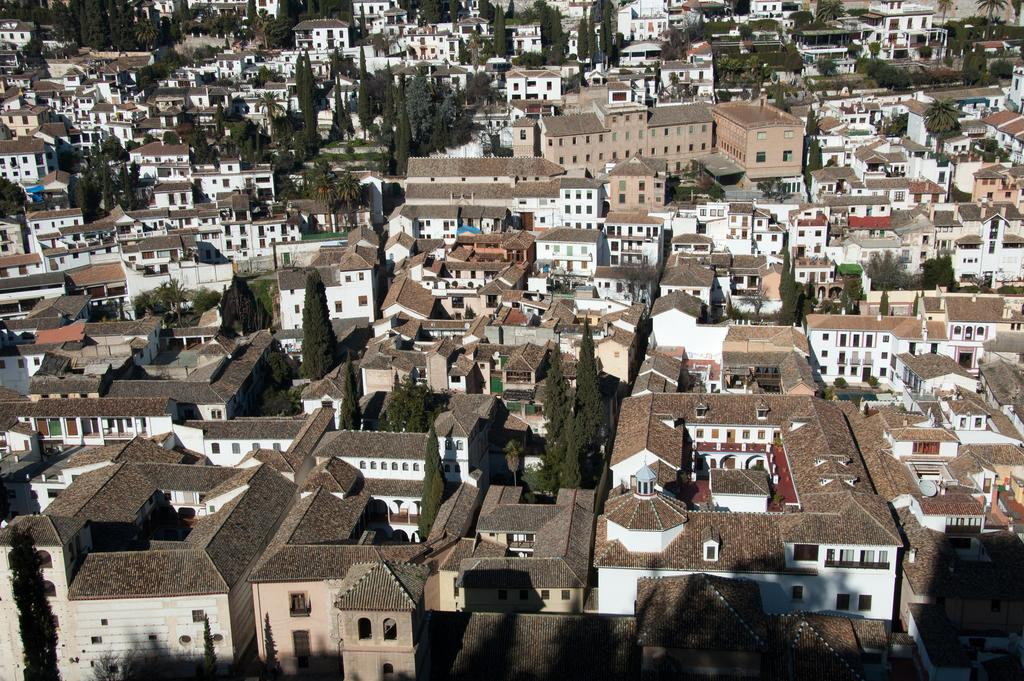What types of structures are visible in the image? There are buildings in the image. What type of vegetation can be seen in the image? There are trees in the image. What types of toys are scattered on the road in the image? There is no road or toys present in the image; it only features buildings and trees. 